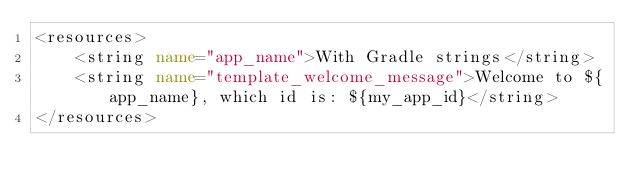<code> <loc_0><loc_0><loc_500><loc_500><_XML_><resources>
    <string name="app_name">With Gradle strings</string>
    <string name="template_welcome_message">Welcome to ${app_name}, which id is: ${my_app_id}</string>
</resources></code> 